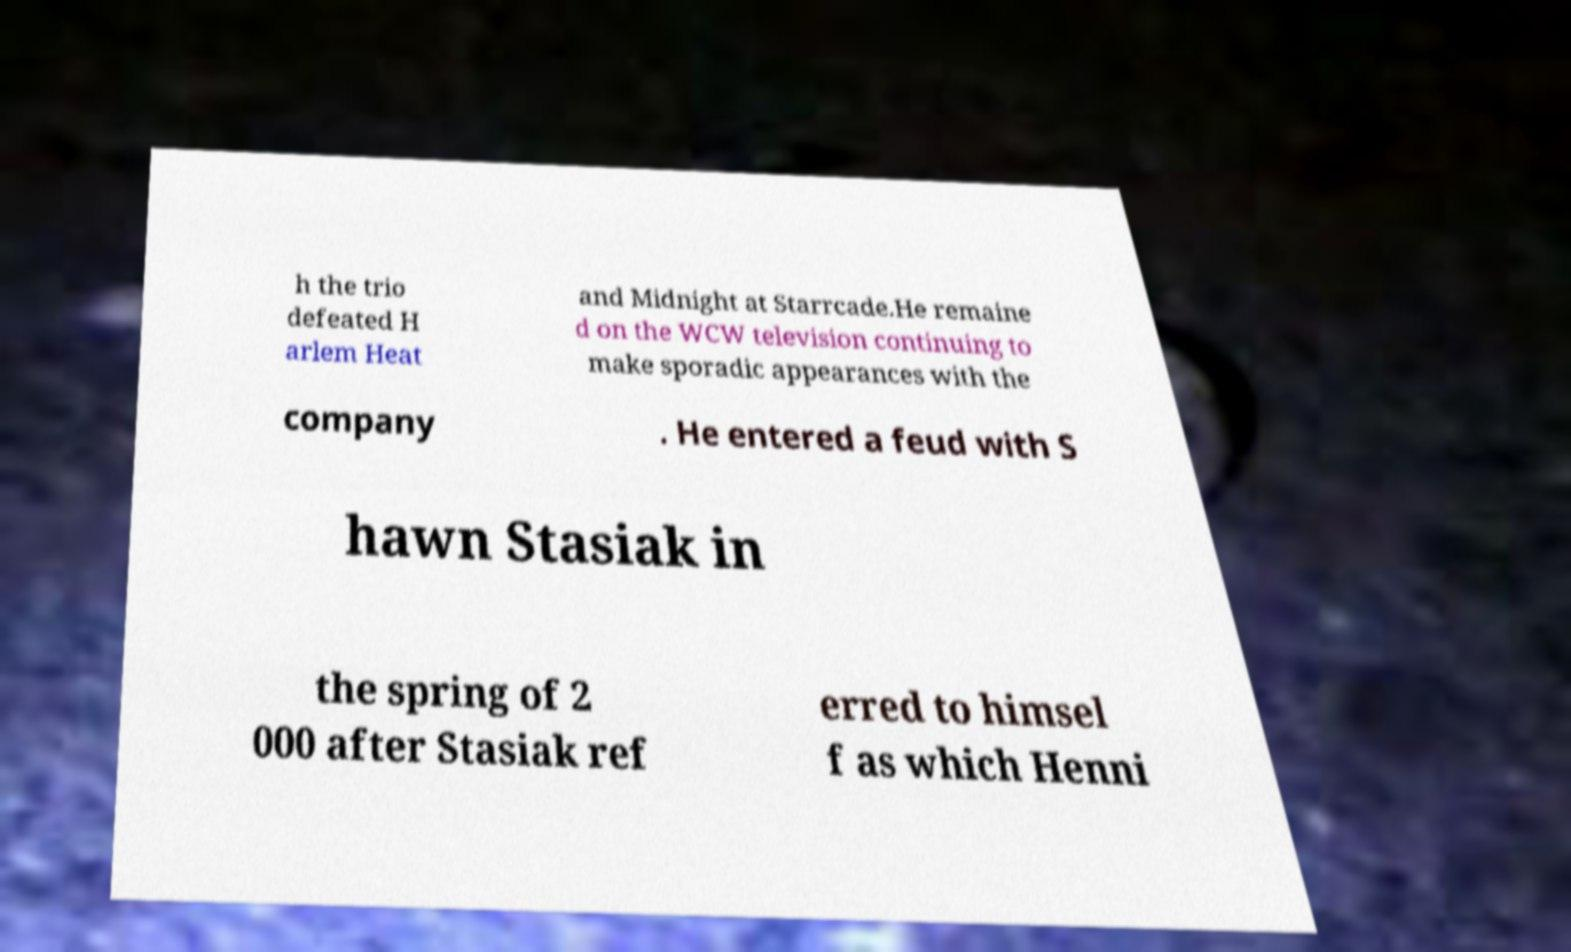For documentation purposes, I need the text within this image transcribed. Could you provide that? h the trio defeated H arlem Heat and Midnight at Starrcade.He remaine d on the WCW television continuing to make sporadic appearances with the company . He entered a feud with S hawn Stasiak in the spring of 2 000 after Stasiak ref erred to himsel f as which Henni 